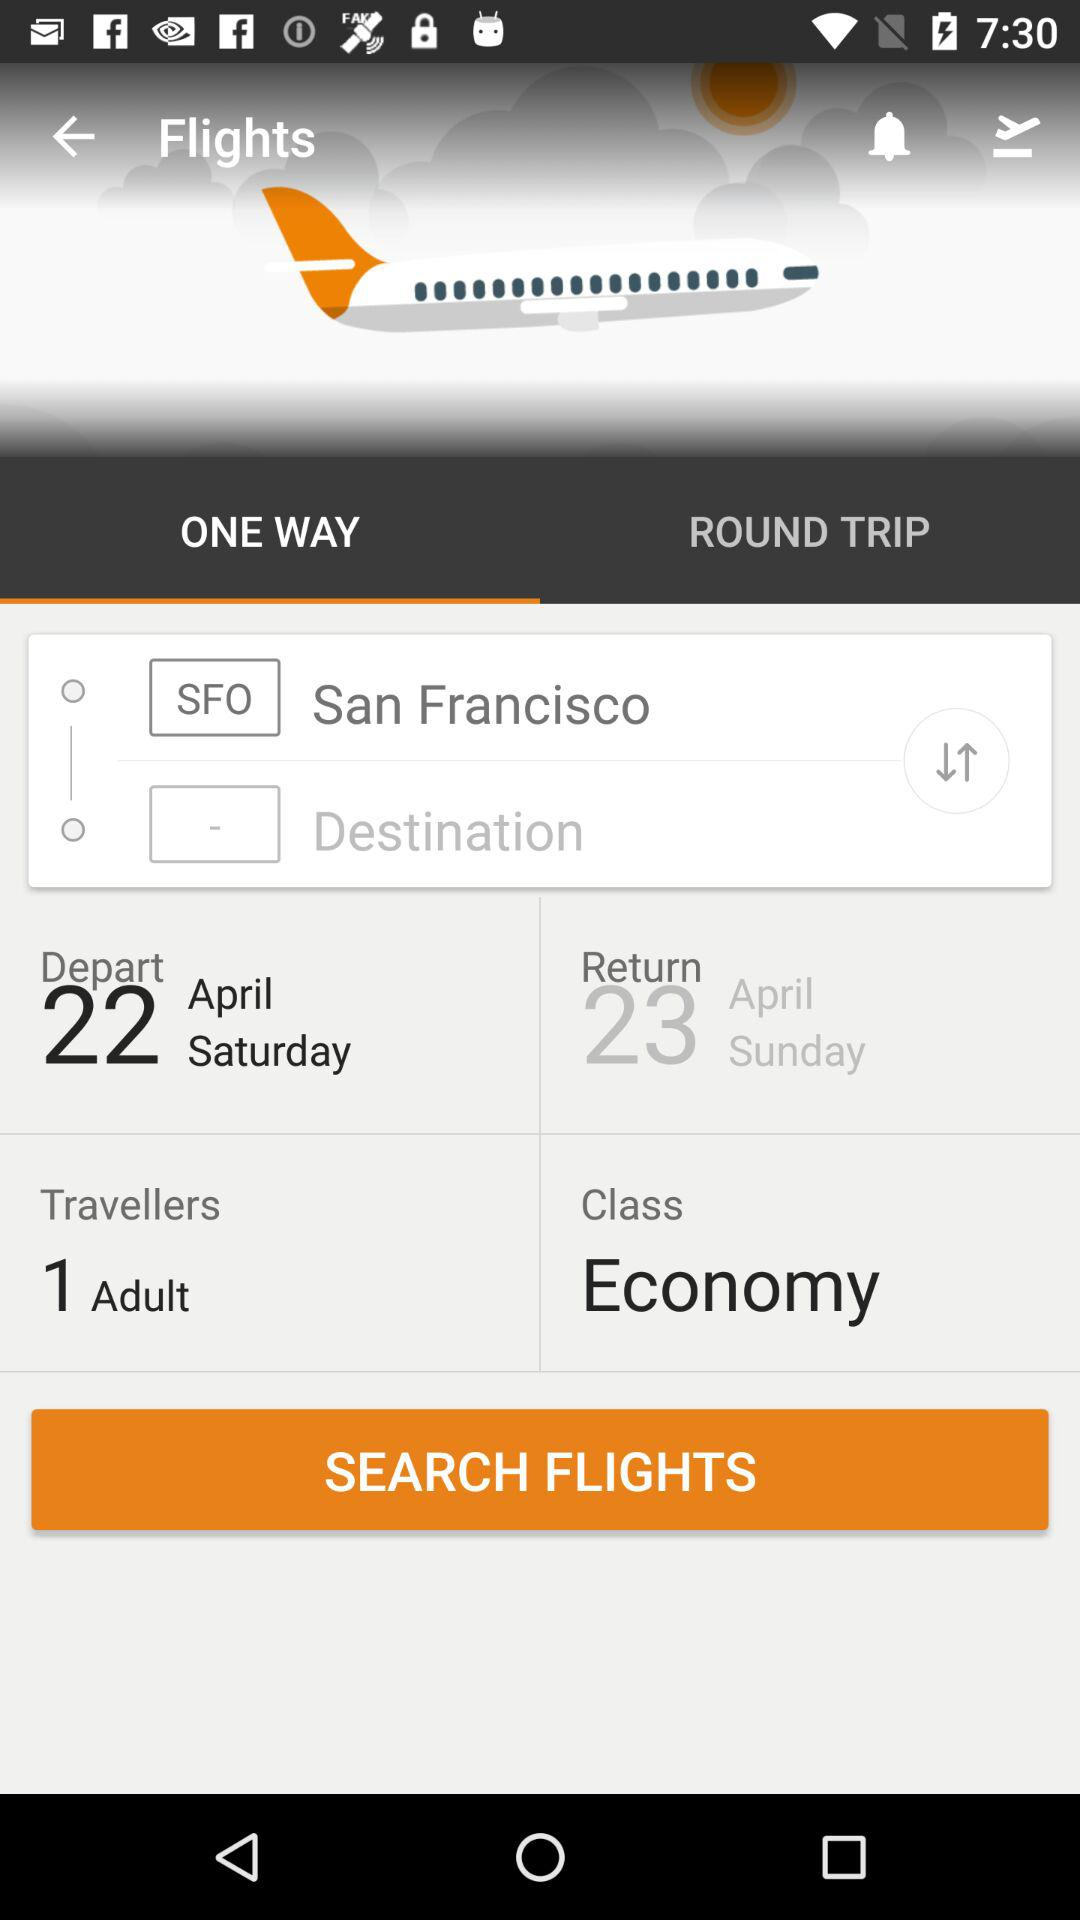What is the return date? The return date is Sunday, April 23. 